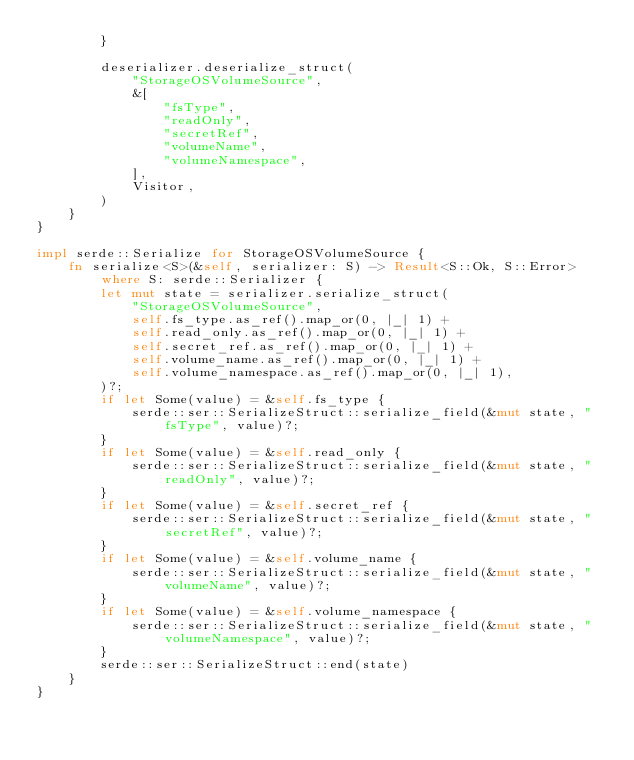Convert code to text. <code><loc_0><loc_0><loc_500><loc_500><_Rust_>        }

        deserializer.deserialize_struct(
            "StorageOSVolumeSource",
            &[
                "fsType",
                "readOnly",
                "secretRef",
                "volumeName",
                "volumeNamespace",
            ],
            Visitor,
        )
    }
}

impl serde::Serialize for StorageOSVolumeSource {
    fn serialize<S>(&self, serializer: S) -> Result<S::Ok, S::Error> where S: serde::Serializer {
        let mut state = serializer.serialize_struct(
            "StorageOSVolumeSource",
            self.fs_type.as_ref().map_or(0, |_| 1) +
            self.read_only.as_ref().map_or(0, |_| 1) +
            self.secret_ref.as_ref().map_or(0, |_| 1) +
            self.volume_name.as_ref().map_or(0, |_| 1) +
            self.volume_namespace.as_ref().map_or(0, |_| 1),
        )?;
        if let Some(value) = &self.fs_type {
            serde::ser::SerializeStruct::serialize_field(&mut state, "fsType", value)?;
        }
        if let Some(value) = &self.read_only {
            serde::ser::SerializeStruct::serialize_field(&mut state, "readOnly", value)?;
        }
        if let Some(value) = &self.secret_ref {
            serde::ser::SerializeStruct::serialize_field(&mut state, "secretRef", value)?;
        }
        if let Some(value) = &self.volume_name {
            serde::ser::SerializeStruct::serialize_field(&mut state, "volumeName", value)?;
        }
        if let Some(value) = &self.volume_namespace {
            serde::ser::SerializeStruct::serialize_field(&mut state, "volumeNamespace", value)?;
        }
        serde::ser::SerializeStruct::end(state)
    }
}
</code> 